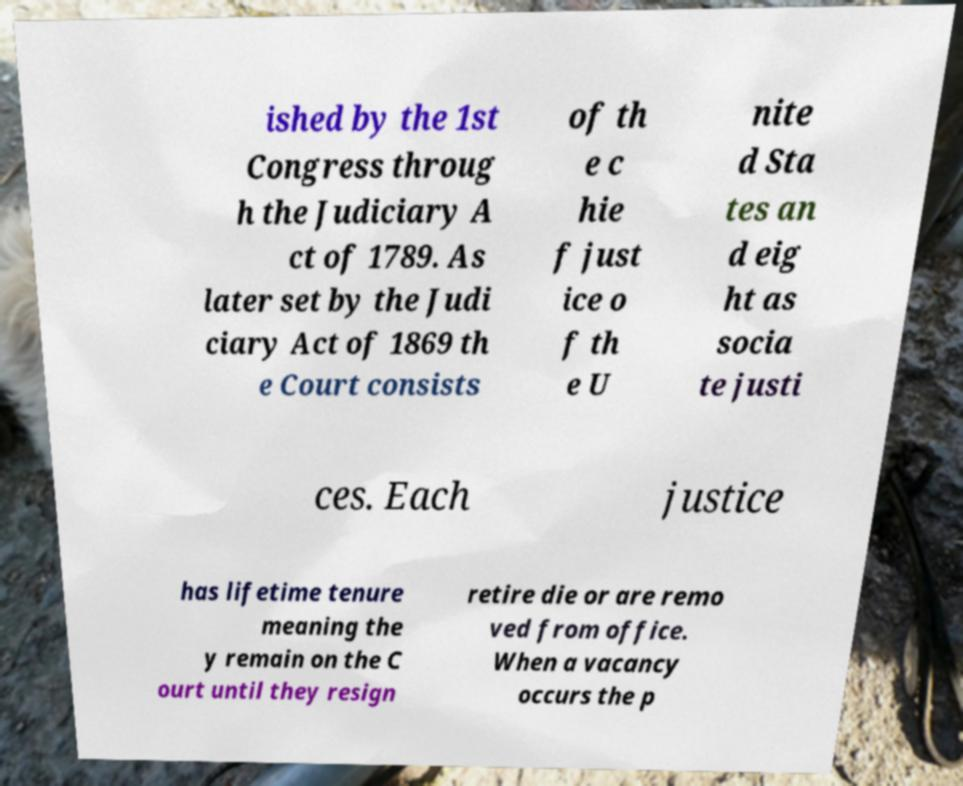What messages or text are displayed in this image? I need them in a readable, typed format. ished by the 1st Congress throug h the Judiciary A ct of 1789. As later set by the Judi ciary Act of 1869 th e Court consists of th e c hie f just ice o f th e U nite d Sta tes an d eig ht as socia te justi ces. Each justice has lifetime tenure meaning the y remain on the C ourt until they resign retire die or are remo ved from office. When a vacancy occurs the p 